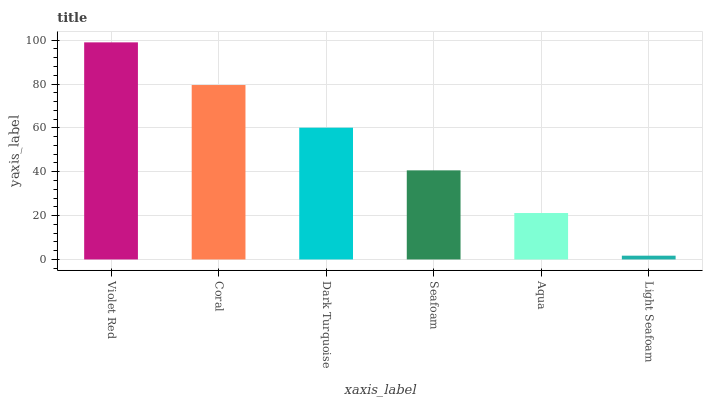Is Light Seafoam the minimum?
Answer yes or no. Yes. Is Violet Red the maximum?
Answer yes or no. Yes. Is Coral the minimum?
Answer yes or no. No. Is Coral the maximum?
Answer yes or no. No. Is Violet Red greater than Coral?
Answer yes or no. Yes. Is Coral less than Violet Red?
Answer yes or no. Yes. Is Coral greater than Violet Red?
Answer yes or no. No. Is Violet Red less than Coral?
Answer yes or no. No. Is Dark Turquoise the high median?
Answer yes or no. Yes. Is Seafoam the low median?
Answer yes or no. Yes. Is Coral the high median?
Answer yes or no. No. Is Dark Turquoise the low median?
Answer yes or no. No. 